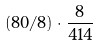<formula> <loc_0><loc_0><loc_500><loc_500>( 8 0 / 8 ) \cdot \frac { 8 } { 4 1 4 }</formula> 